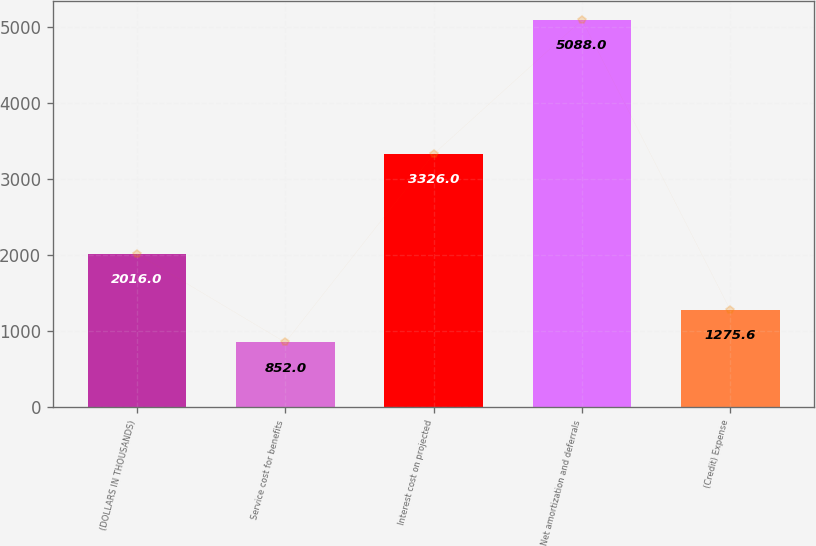Convert chart to OTSL. <chart><loc_0><loc_0><loc_500><loc_500><bar_chart><fcel>(DOLLARS IN THOUSANDS)<fcel>Service cost for benefits<fcel>Interest cost on projected<fcel>Net amortization and deferrals<fcel>(Credit) Expense<nl><fcel>2016<fcel>852<fcel>3326<fcel>5088<fcel>1275.6<nl></chart> 